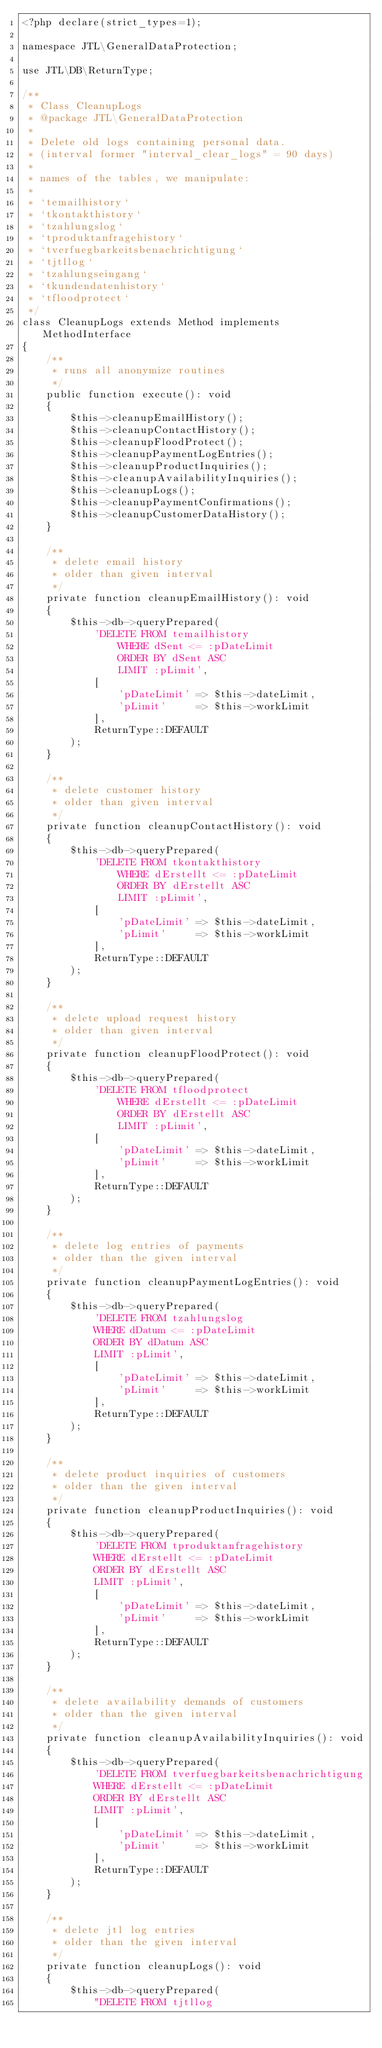<code> <loc_0><loc_0><loc_500><loc_500><_PHP_><?php declare(strict_types=1);

namespace JTL\GeneralDataProtection;

use JTL\DB\ReturnType;

/**
 * Class CleanupLogs
 * @package JTL\GeneralDataProtection
 *
 * Delete old logs containing personal data.
 * (interval former "interval_clear_logs" = 90 days)
 *
 * names of the tables, we manipulate:
 *
 * `temailhistory`
 * `tkontakthistory`
 * `tzahlungslog`
 * `tproduktanfragehistory`
 * `tverfuegbarkeitsbenachrichtigung`
 * `tjtllog`
 * `tzahlungseingang`
 * `tkundendatenhistory`
 * `tfloodprotect`
 */
class CleanupLogs extends Method implements MethodInterface
{
    /**
     * runs all anonymize routines
     */
    public function execute(): void
    {
        $this->cleanupEmailHistory();
        $this->cleanupContactHistory();
        $this->cleanupFloodProtect();
        $this->cleanupPaymentLogEntries();
        $this->cleanupProductInquiries();
        $this->cleanupAvailabilityInquiries();
        $this->cleanupLogs();
        $this->cleanupPaymentConfirmations();
        $this->cleanupCustomerDataHistory();
    }

    /**
     * delete email history
     * older than given interval
     */
    private function cleanupEmailHistory(): void
    {
        $this->db->queryPrepared(
            'DELETE FROM temailhistory
                WHERE dSent <= :pDateLimit
                ORDER BY dSent ASC
                LIMIT :pLimit',
            [
                'pDateLimit' => $this->dateLimit,
                'pLimit'     => $this->workLimit
            ],
            ReturnType::DEFAULT
        );
    }

    /**
     * delete customer history
     * older than given interval
     */
    private function cleanupContactHistory(): void
    {
        $this->db->queryPrepared(
            'DELETE FROM tkontakthistory
                WHERE dErstellt <= :pDateLimit
                ORDER BY dErstellt ASC
                LIMIT :pLimit',
            [
                'pDateLimit' => $this->dateLimit,
                'pLimit'     => $this->workLimit
            ],
            ReturnType::DEFAULT
        );
    }

    /**
     * delete upload request history
     * older than given interval
     */
    private function cleanupFloodProtect(): void
    {
        $this->db->queryPrepared(
            'DELETE FROM tfloodprotect
                WHERE dErstellt <= :pDateLimit
                ORDER BY dErstellt ASC
                LIMIT :pLimit',
            [
                'pDateLimit' => $this->dateLimit,
                'pLimit'     => $this->workLimit
            ],
            ReturnType::DEFAULT
        );
    }

    /**
     * delete log entries of payments
     * older than the given interval
     */
    private function cleanupPaymentLogEntries(): void
    {
        $this->db->queryPrepared(
            'DELETE FROM tzahlungslog
            WHERE dDatum <= :pDateLimit
            ORDER BY dDatum ASC
            LIMIT :pLimit',
            [
                'pDateLimit' => $this->dateLimit,
                'pLimit'     => $this->workLimit
            ],
            ReturnType::DEFAULT
        );
    }

    /**
     * delete product inquiries of customers
     * older than the given interval
     */
    private function cleanupProductInquiries(): void
    {
        $this->db->queryPrepared(
            'DELETE FROM tproduktanfragehistory
            WHERE dErstellt <= :pDateLimit
            ORDER BY dErstellt ASC
            LIMIT :pLimit',
            [
                'pDateLimit' => $this->dateLimit,
                'pLimit'     => $this->workLimit
            ],
            ReturnType::DEFAULT
        );
    }

    /**
     * delete availability demands of customers
     * older than the given interval
     */
    private function cleanupAvailabilityInquiries(): void
    {
        $this->db->queryPrepared(
            'DELETE FROM tverfuegbarkeitsbenachrichtigung
            WHERE dErstellt <= :pDateLimit
            ORDER BY dErstellt ASC
            LIMIT :pLimit',
            [
                'pDateLimit' => $this->dateLimit,
                'pLimit'     => $this->workLimit
            ],
            ReturnType::DEFAULT
        );
    }

    /**
     * delete jtl log entries
     * older than the given interval
     */
    private function cleanupLogs(): void
    {
        $this->db->queryPrepared(
            "DELETE FROM tjtllog</code> 